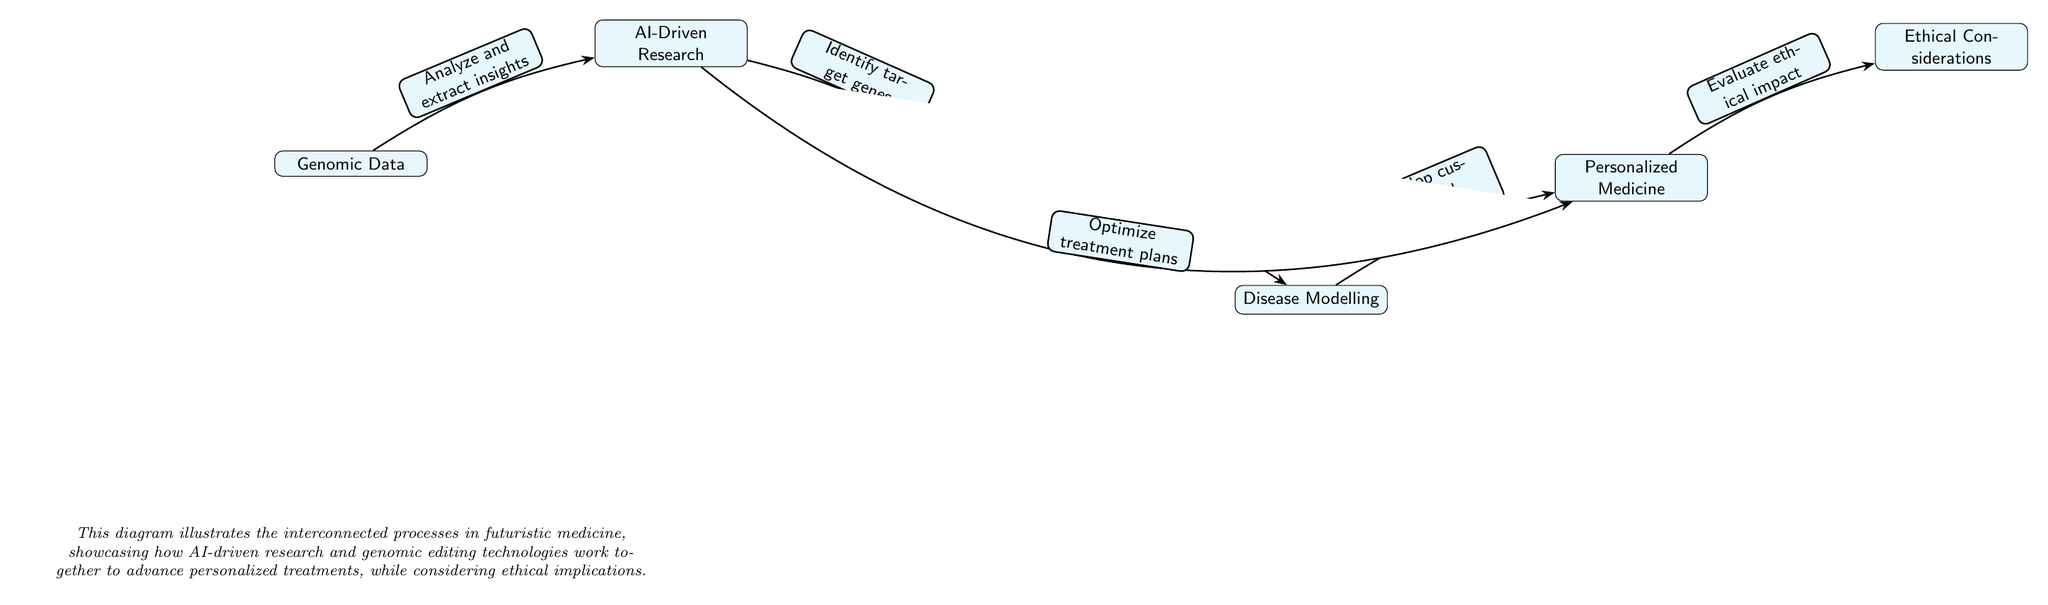What is the first node in the diagram? The first node in the diagram is "Genomic Data," which is located at the beginning of the flow.
Answer: Genomic Data How many nodes are there in total? The diagram contains six nodes connected sequentially, each representing different steps in the process.
Answer: Six What relationship exists between AI-Driven Research and Gene Editing Tools? There is a directed edge labeled "Identify target genes" that connects AI-Driven Research to Gene Editing Tools, indicating a specific action or relationship.
Answer: Identify target genes What follows Disease Modelling in the flow? The node that follows Disease Modelling is "Personalized Medicine," showing the next step in the treatment development process.
Answer: Personalized Medicine What is the last node in this process? The last node is "Ethical Considerations," which is the endpoint representing the consideration required after developing personalized medicine.
Answer: Ethical Considerations What two nodes are directly connected to Gene Editing Tools? Gene Editing Tools is directly connected to AI-Driven Research, leading into it, and to Disease Modelling, which is a subsequent step.
Answer: AI-Driven Research and Disease Modelling How does AI-Driven Research optimize treatment plans in the diagram? AI-Driven Research is shown to connect to Personalized Medicine with a bidirectional edge labeled "Optimize treatment plans," showcasing a reciprocal relationship between the two.
Answer: Optimize treatment plans What is the function of the edge between Personalized Medicine and Ethical Considerations? The edge indicates the process of evaluating the ethical impact of the treatments developed under Personalized Medicine, highlighting an important assessment stage.
Answer: Evaluate ethical impact What role does Disease Modelling play in the context of gene editing? Disease Modelling follows the modification of genes. It represents the exploration of the effects of those modifications on health conditions.
Answer: Modify genes to study effects 